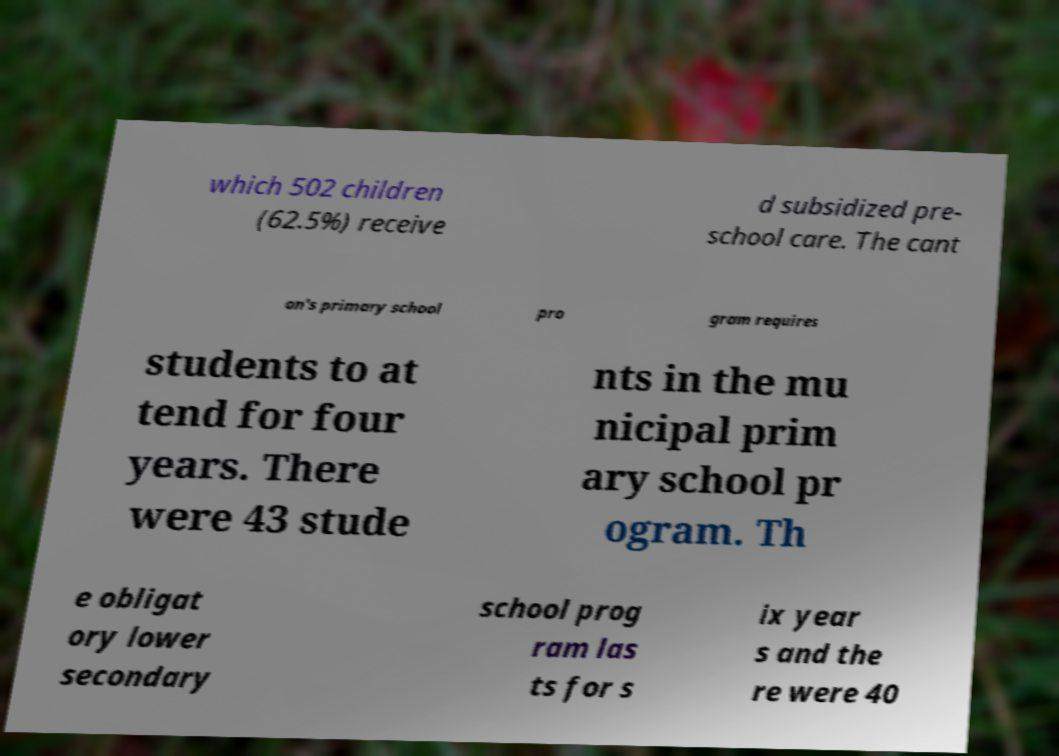For documentation purposes, I need the text within this image transcribed. Could you provide that? which 502 children (62.5%) receive d subsidized pre- school care. The cant on's primary school pro gram requires students to at tend for four years. There were 43 stude nts in the mu nicipal prim ary school pr ogram. Th e obligat ory lower secondary school prog ram las ts for s ix year s and the re were 40 